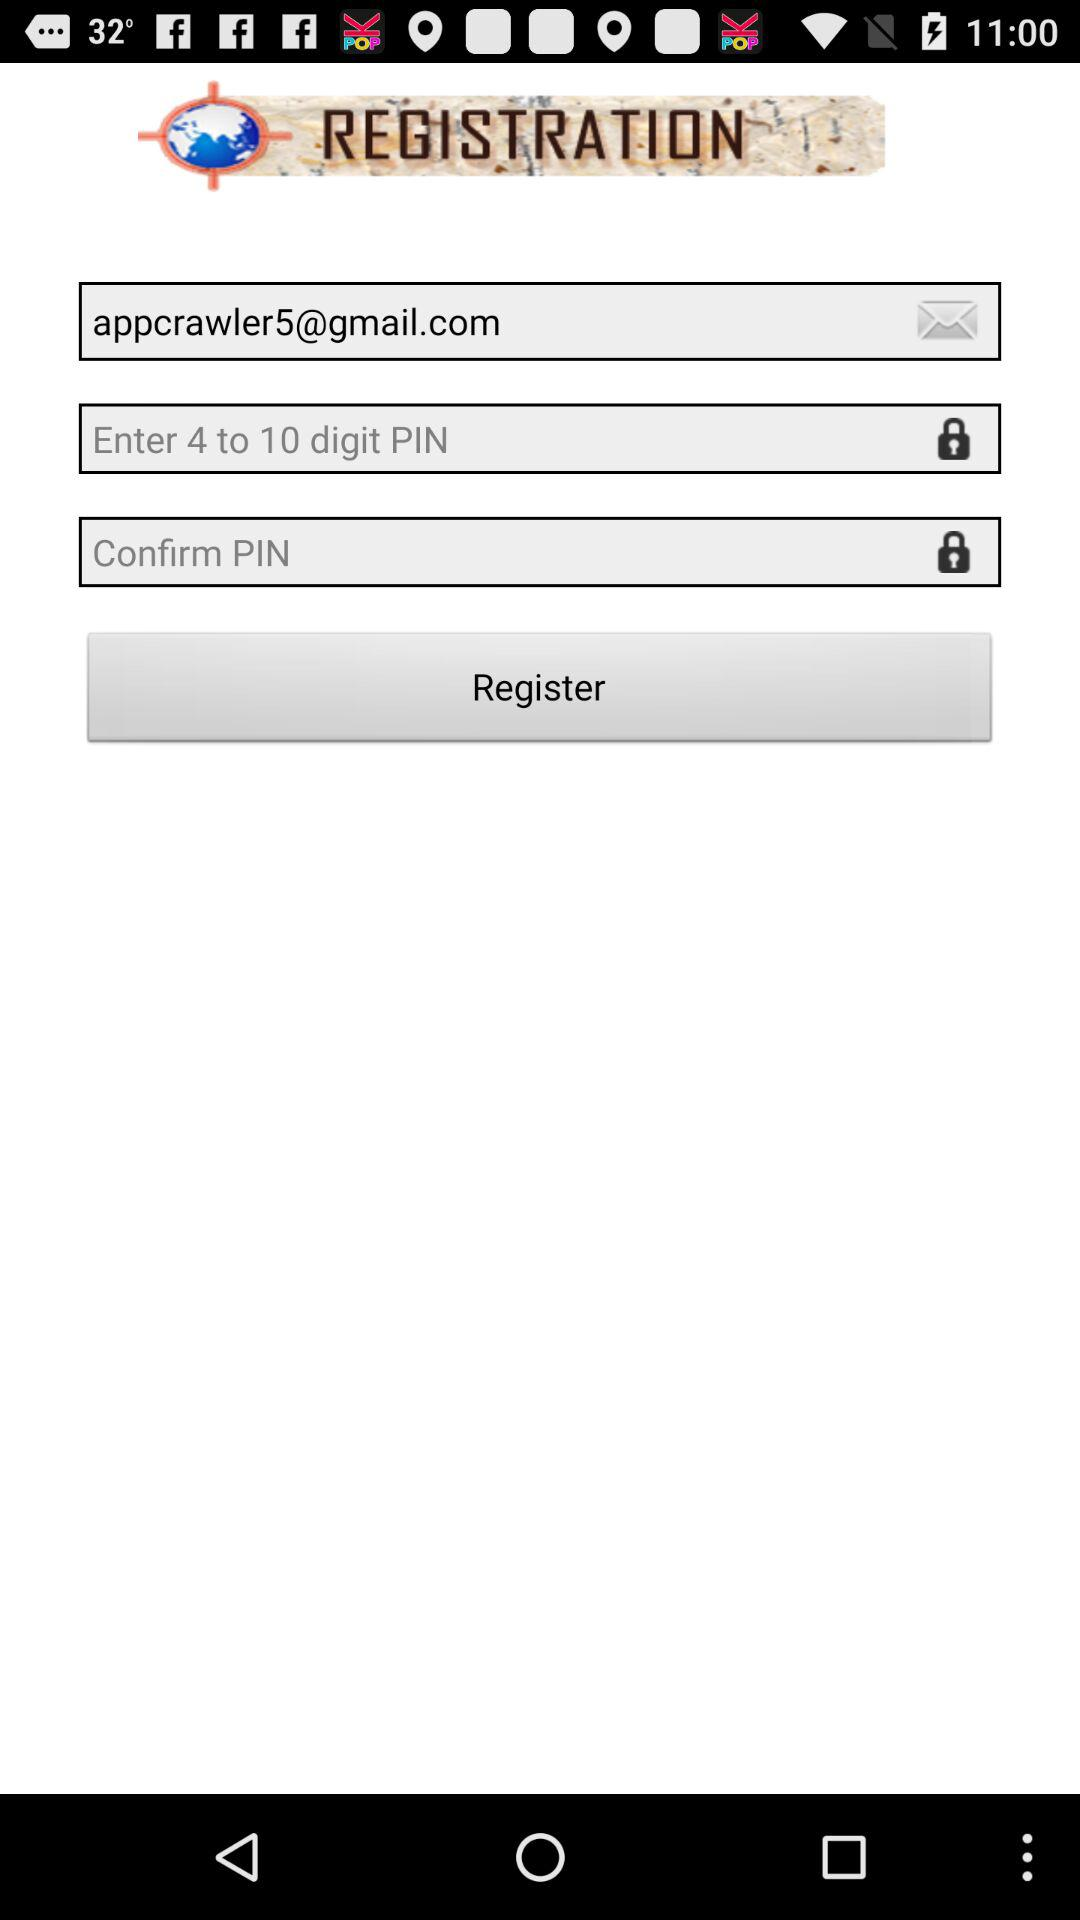What is the email address? The email address is appcrawler5@gmail.com. 